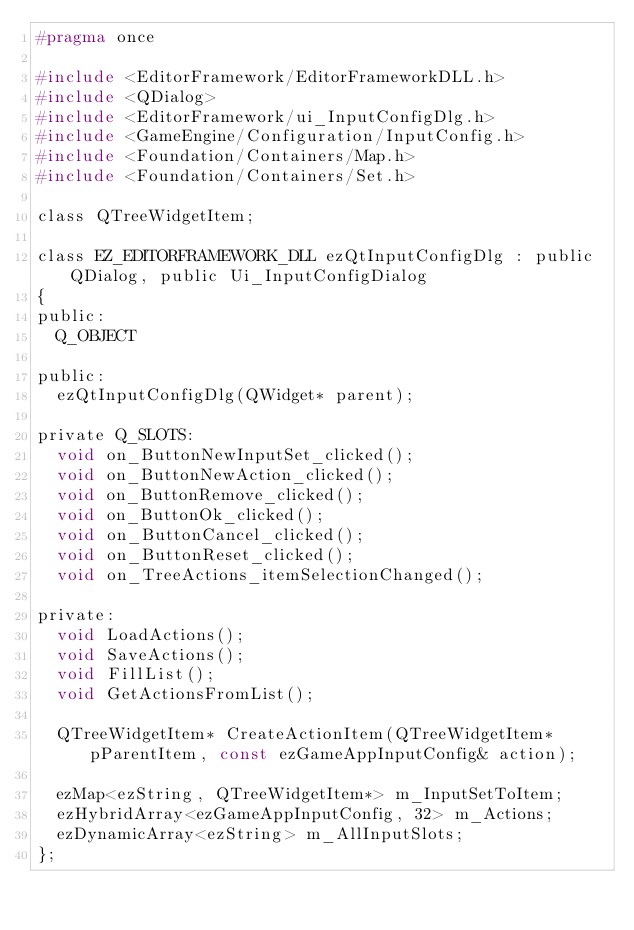Convert code to text. <code><loc_0><loc_0><loc_500><loc_500><_C_>#pragma once

#include <EditorFramework/EditorFrameworkDLL.h>
#include <QDialog>
#include <EditorFramework/ui_InputConfigDlg.h>
#include <GameEngine/Configuration/InputConfig.h>
#include <Foundation/Containers/Map.h>
#include <Foundation/Containers/Set.h>

class QTreeWidgetItem;

class EZ_EDITORFRAMEWORK_DLL ezQtInputConfigDlg : public QDialog, public Ui_InputConfigDialog
{
public:
  Q_OBJECT

public:
  ezQtInputConfigDlg(QWidget* parent);

private Q_SLOTS:
  void on_ButtonNewInputSet_clicked();
  void on_ButtonNewAction_clicked();
  void on_ButtonRemove_clicked();
  void on_ButtonOk_clicked();
  void on_ButtonCancel_clicked();
  void on_ButtonReset_clicked();
  void on_TreeActions_itemSelectionChanged();

private:
  void LoadActions();
  void SaveActions();
  void FillList();
  void GetActionsFromList();

  QTreeWidgetItem* CreateActionItem(QTreeWidgetItem* pParentItem, const ezGameAppInputConfig& action);

  ezMap<ezString, QTreeWidgetItem*> m_InputSetToItem;
  ezHybridArray<ezGameAppInputConfig, 32> m_Actions;
  ezDynamicArray<ezString> m_AllInputSlots;
};


</code> 